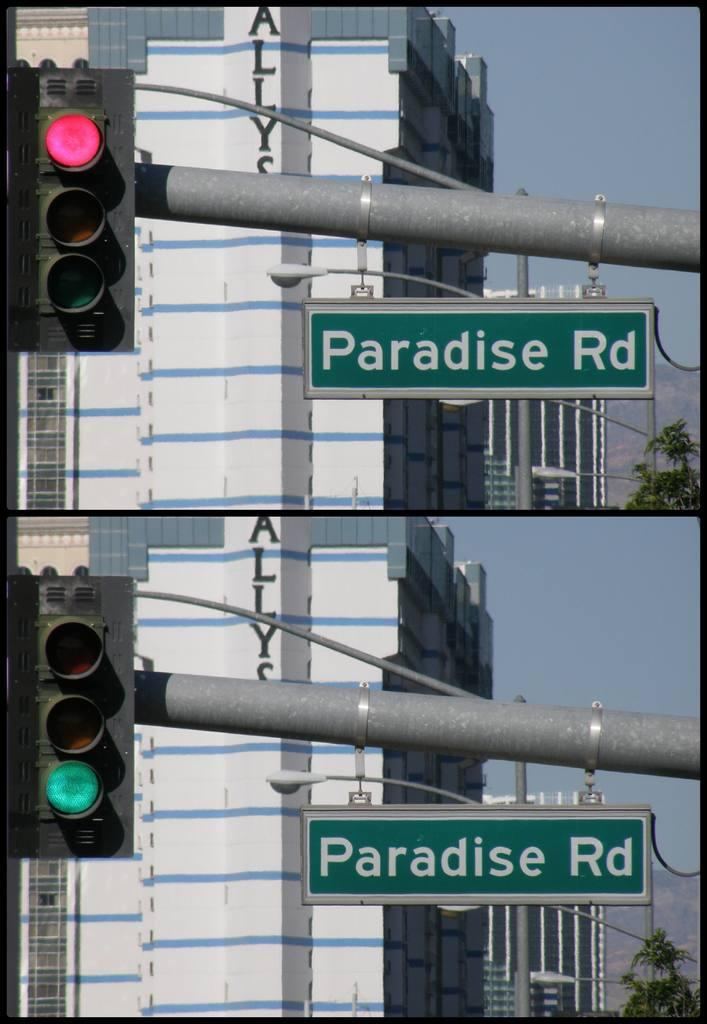Provide a one-sentence caption for the provided image. a couple of green road signs that say Paradise Rd. 